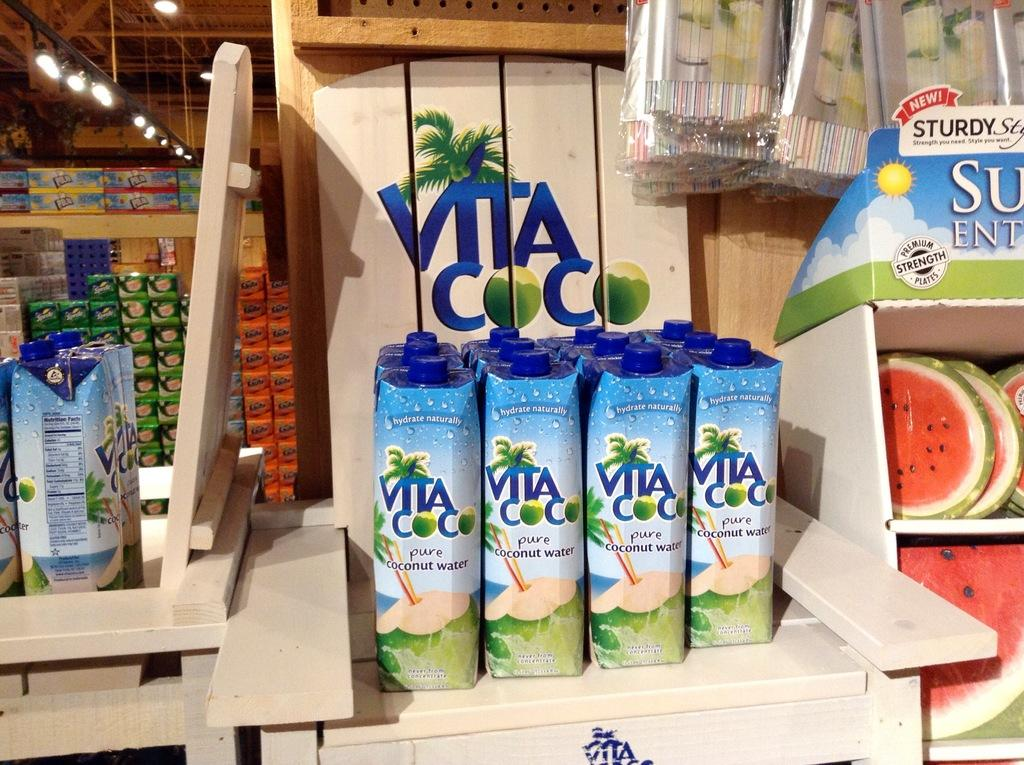Provide a one-sentence caption for the provided image. Several containers of Vita Coco are on display. 